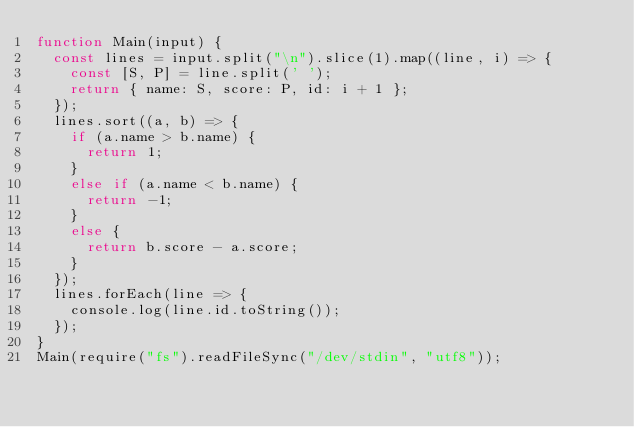Convert code to text. <code><loc_0><loc_0><loc_500><loc_500><_JavaScript_>function Main(input) {
  const lines = input.split("\n").slice(1).map((line, i) => {
    const [S, P] = line.split(' ');
    return { name: S, score: P, id: i + 1 };
  });
  lines.sort((a, b) => {
    if (a.name > b.name) {
      return 1;
    }
    else if (a.name < b.name) {
      return -1;
    }
    else {
      return b.score - a.score;
    }
  });
  lines.forEach(line => {
    console.log(line.id.toString());
  });
}
Main(require("fs").readFileSync("/dev/stdin", "utf8"));</code> 